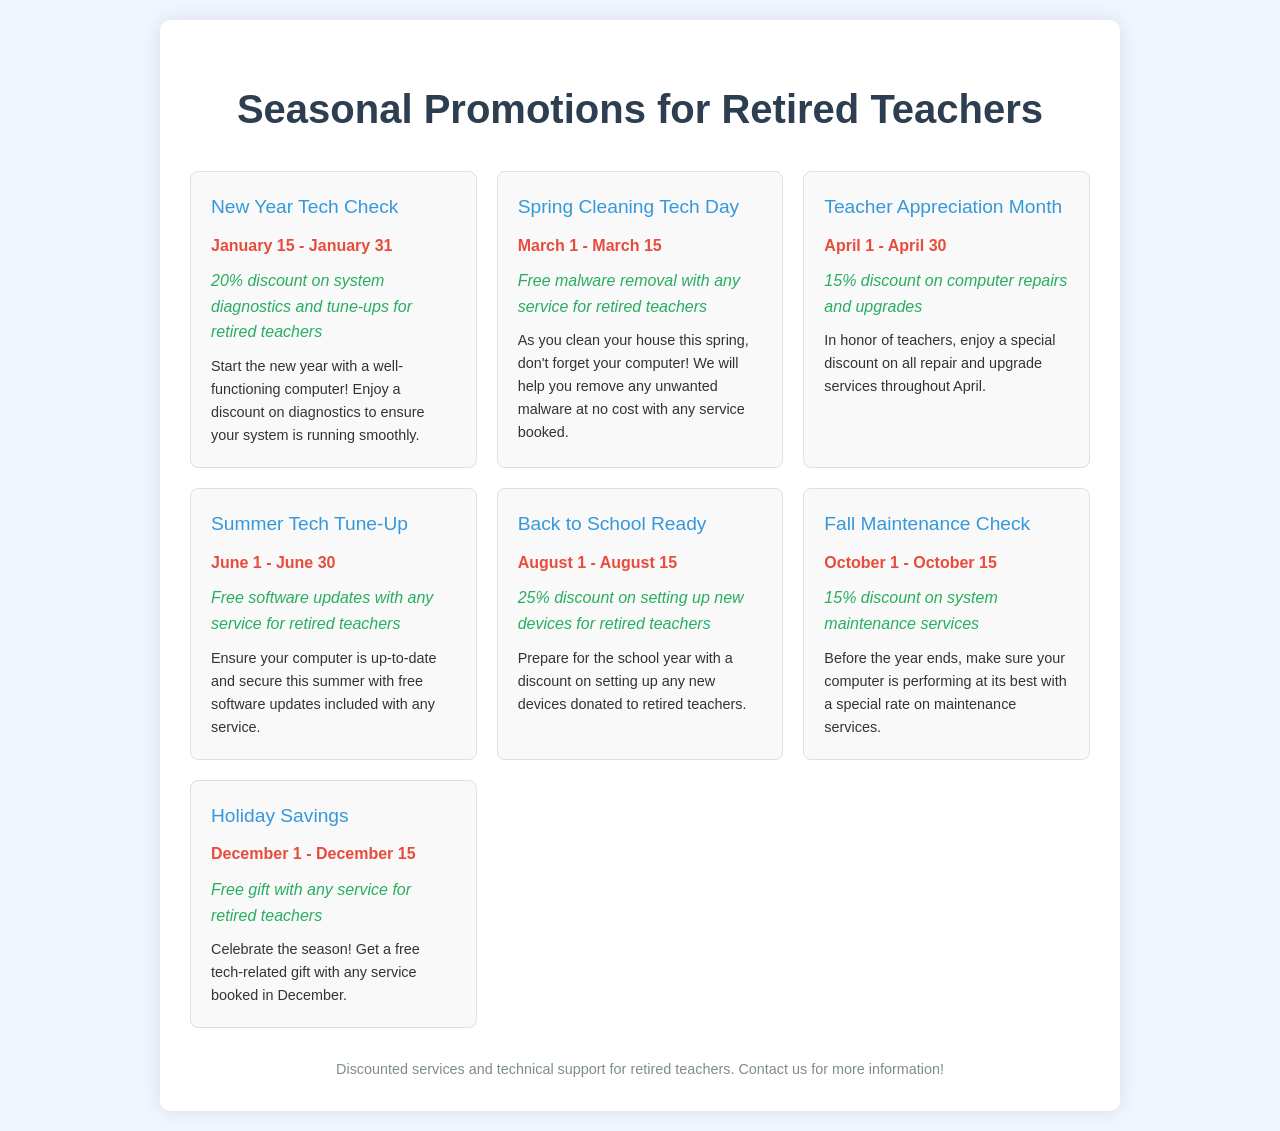What is the title of the first promotion? The title of the first promotion is "New Year Tech Check."
Answer: New Year Tech Check What is the discount offered during Teacher Appreciation Month? The discount offered during Teacher Appreciation Month is 15% on computer repairs and upgrades.
Answer: 15% When does the Spring Cleaning Tech Day promotion take place? The Spring Cleaning Tech Day promotion takes place from March 1 to March 15.
Answer: March 1 - March 15 What special offer is available during the Summer Tech Tune-Up? The special offer during the Summer Tech Tune-Up is free software updates with any service.
Answer: Free software updates How much is the discount for setting up new devices in the Back to School Ready promotion? The discount for setting up new devices is 25%.
Answer: 25% What do retired teachers receive during the Holiday Savings promotion? Retired teachers receive a free gift with any service during the Holiday Savings promotion.
Answer: Free gift Which promotion has the longest duration? The promotion with the longest duration is Teacher Appreciation Month, lasting all month long.
Answer: Teacher Appreciation Month What type of services is included in the Fall Maintenance Check offer? The Fall Maintenance Check offer includes system maintenance services.
Answer: System maintenance services 